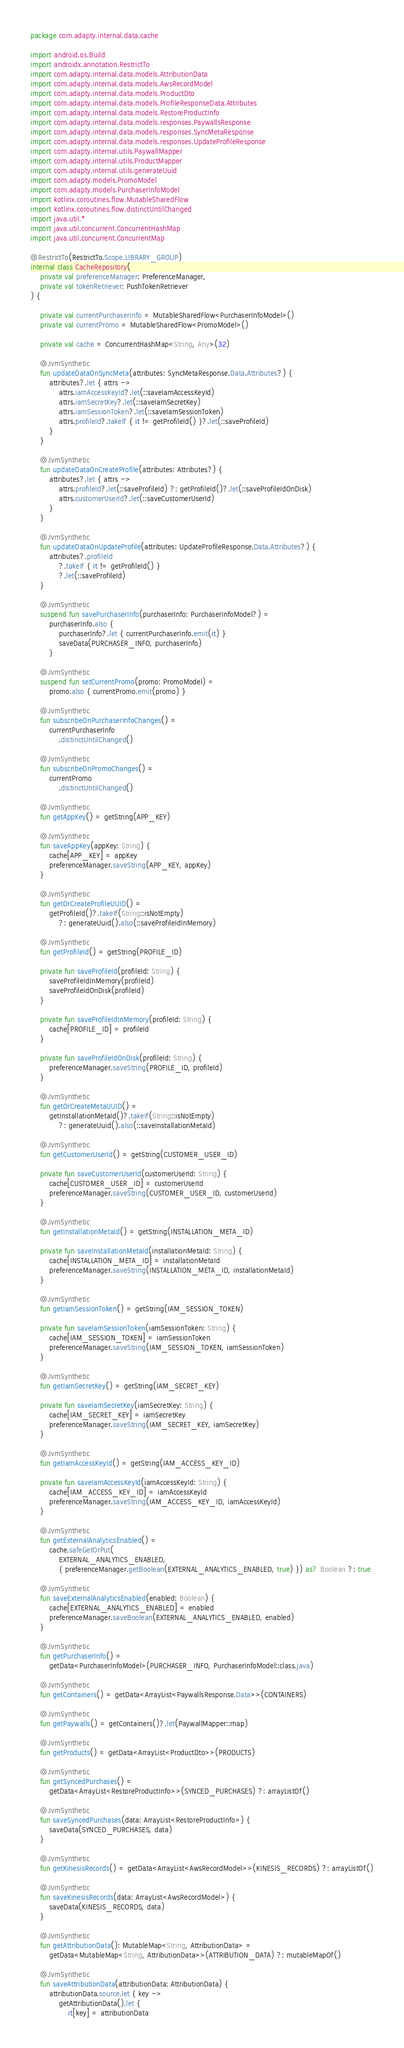Convert code to text. <code><loc_0><loc_0><loc_500><loc_500><_Kotlin_>package com.adapty.internal.data.cache

import android.os.Build
import androidx.annotation.RestrictTo
import com.adapty.internal.data.models.AttributionData
import com.adapty.internal.data.models.AwsRecordModel
import com.adapty.internal.data.models.ProductDto
import com.adapty.internal.data.models.ProfileResponseData.Attributes
import com.adapty.internal.data.models.RestoreProductInfo
import com.adapty.internal.data.models.responses.PaywallsResponse
import com.adapty.internal.data.models.responses.SyncMetaResponse
import com.adapty.internal.data.models.responses.UpdateProfileResponse
import com.adapty.internal.utils.PaywallMapper
import com.adapty.internal.utils.ProductMapper
import com.adapty.internal.utils.generateUuid
import com.adapty.models.PromoModel
import com.adapty.models.PurchaserInfoModel
import kotlinx.coroutines.flow.MutableSharedFlow
import kotlinx.coroutines.flow.distinctUntilChanged
import java.util.*
import java.util.concurrent.ConcurrentHashMap
import java.util.concurrent.ConcurrentMap

@RestrictTo(RestrictTo.Scope.LIBRARY_GROUP)
internal class CacheRepository(
    private val preferenceManager: PreferenceManager,
    private val tokenRetriever: PushTokenRetriever
) {

    private val currentPurchaserInfo = MutableSharedFlow<PurchaserInfoModel>()
    private val currentPromo = MutableSharedFlow<PromoModel>()

    private val cache = ConcurrentHashMap<String, Any>(32)

    @JvmSynthetic
    fun updateDataOnSyncMeta(attributes: SyncMetaResponse.Data.Attributes?) {
        attributes?.let { attrs ->
            attrs.iamAccessKeyId?.let(::saveIamAccessKeyId)
            attrs.iamSecretKey?.let(::saveIamSecretKey)
            attrs.iamSessionToken?.let(::saveIamSessionToken)
            attrs.profileId?.takeIf { it != getProfileId() }?.let(::saveProfileId)
        }
    }

    @JvmSynthetic
    fun updateDataOnCreateProfile(attributes: Attributes?) {
        attributes?.let { attrs ->
            attrs.profileId?.let(::saveProfileId) ?: getProfileId()?.let(::saveProfileIdOnDisk)
            attrs.customerUserId?.let(::saveCustomerUserId)
        }
    }

    @JvmSynthetic
    fun updateDataOnUpdateProfile(attributes: UpdateProfileResponse.Data.Attributes?) {
        attributes?.profileId
            ?.takeIf { it != getProfileId() }
            ?.let(::saveProfileId)
    }

    @JvmSynthetic
    suspend fun savePurchaserInfo(purchaserInfo: PurchaserInfoModel?) =
        purchaserInfo.also {
            purchaserInfo?.let { currentPurchaserInfo.emit(it) }
            saveData(PURCHASER_INFO, purchaserInfo)
        }

    @JvmSynthetic
    suspend fun setCurrentPromo(promo: PromoModel) =
        promo.also { currentPromo.emit(promo) }

    @JvmSynthetic
    fun subscribeOnPurchaserInfoChanges() =
        currentPurchaserInfo
            .distinctUntilChanged()

    @JvmSynthetic
    fun subscribeOnPromoChanges() =
        currentPromo
            .distinctUntilChanged()

    @JvmSynthetic
    fun getAppKey() = getString(APP_KEY)

    @JvmSynthetic
    fun saveAppKey(appKey: String) {
        cache[APP_KEY] = appKey
        preferenceManager.saveString(APP_KEY, appKey)
    }

    @JvmSynthetic
    fun getOrCreateProfileUUID() =
        getProfileId()?.takeIf(String::isNotEmpty)
            ?: generateUuid().also(::saveProfileIdInMemory)

    @JvmSynthetic
    fun getProfileId() = getString(PROFILE_ID)

    private fun saveProfileId(profileId: String) {
        saveProfileIdInMemory(profileId)
        saveProfileIdOnDisk(profileId)
    }

    private fun saveProfileIdInMemory(profileId: String) {
        cache[PROFILE_ID] = profileId
    }

    private fun saveProfileIdOnDisk(profileId: String) {
        preferenceManager.saveString(PROFILE_ID, profileId)
    }

    @JvmSynthetic
    fun getOrCreateMetaUUID() =
        getInstallationMetaId()?.takeIf(String::isNotEmpty)
            ?: generateUuid().also(::saveInstallationMetaId)

    @JvmSynthetic
    fun getCustomerUserId() = getString(CUSTOMER_USER_ID)

    private fun saveCustomerUserId(customerUserId: String) {
        cache[CUSTOMER_USER_ID] = customerUserId
        preferenceManager.saveString(CUSTOMER_USER_ID, customerUserId)
    }

    @JvmSynthetic
    fun getInstallationMetaId() = getString(INSTALLATION_META_ID)

    private fun saveInstallationMetaId(installationMetaId: String) {
        cache[INSTALLATION_META_ID] = installationMetaId
        preferenceManager.saveString(INSTALLATION_META_ID, installationMetaId)
    }

    @JvmSynthetic
    fun getIamSessionToken() = getString(IAM_SESSION_TOKEN)

    private fun saveIamSessionToken(iamSessionToken: String) {
        cache[IAM_SESSION_TOKEN] = iamSessionToken
        preferenceManager.saveString(IAM_SESSION_TOKEN, iamSessionToken)
    }

    @JvmSynthetic
    fun getIamSecretKey() = getString(IAM_SECRET_KEY)

    private fun saveIamSecretKey(iamSecretKey: String) {
        cache[IAM_SECRET_KEY] = iamSecretKey
        preferenceManager.saveString(IAM_SECRET_KEY, iamSecretKey)
    }

    @JvmSynthetic
    fun getIamAccessKeyId() = getString(IAM_ACCESS_KEY_ID)

    private fun saveIamAccessKeyId(iamAccessKeyId: String) {
        cache[IAM_ACCESS_KEY_ID] = iamAccessKeyId
        preferenceManager.saveString(IAM_ACCESS_KEY_ID, iamAccessKeyId)
    }

    @JvmSynthetic
    fun getExternalAnalyticsEnabled() =
        cache.safeGetOrPut(
            EXTERNAL_ANALYTICS_ENABLED,
            { preferenceManager.getBoolean(EXTERNAL_ANALYTICS_ENABLED, true) }) as? Boolean ?: true

    @JvmSynthetic
    fun saveExternalAnalyticsEnabled(enabled: Boolean) {
        cache[EXTERNAL_ANALYTICS_ENABLED] = enabled
        preferenceManager.saveBoolean(EXTERNAL_ANALYTICS_ENABLED, enabled)
    }

    @JvmSynthetic
    fun getPurchaserInfo() =
        getData<PurchaserInfoModel>(PURCHASER_INFO, PurchaserInfoModel::class.java)

    @JvmSynthetic
    fun getContainers() = getData<ArrayList<PaywallsResponse.Data>>(CONTAINERS)

    @JvmSynthetic
    fun getPaywalls() = getContainers()?.let(PaywallMapper::map)

    @JvmSynthetic
    fun getProducts() = getData<ArrayList<ProductDto>>(PRODUCTS)

    @JvmSynthetic
    fun getSyncedPurchases() =
        getData<ArrayList<RestoreProductInfo>>(SYNCED_PURCHASES) ?: arrayListOf()

    @JvmSynthetic
    fun saveSyncedPurchases(data: ArrayList<RestoreProductInfo>) {
        saveData(SYNCED_PURCHASES, data)
    }

    @JvmSynthetic
    fun getKinesisRecords() = getData<ArrayList<AwsRecordModel>>(KINESIS_RECORDS) ?: arrayListOf()

    @JvmSynthetic
    fun saveKinesisRecords(data: ArrayList<AwsRecordModel>) {
        saveData(KINESIS_RECORDS, data)
    }

    @JvmSynthetic
    fun getAttributionData(): MutableMap<String, AttributionData> =
        getData<MutableMap<String, AttributionData>>(ATTRIBUTION_DATA) ?: mutableMapOf()

    @JvmSynthetic
    fun saveAttributionData(attributionData: AttributionData) {
        attributionData.source.let { key ->
            getAttributionData().let {
                it[key] = attributionData</code> 